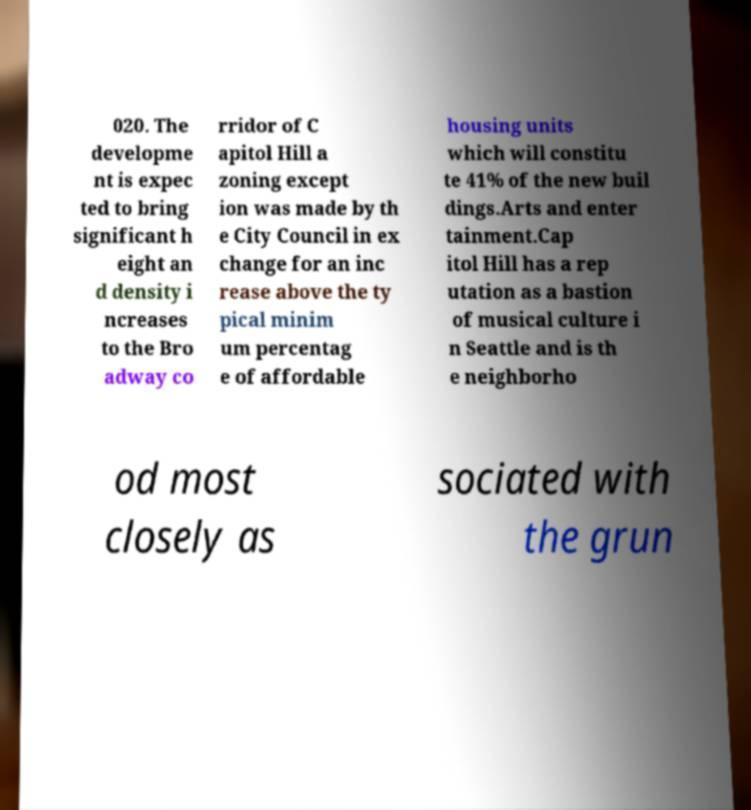There's text embedded in this image that I need extracted. Can you transcribe it verbatim? 020. The developme nt is expec ted to bring significant h eight an d density i ncreases to the Bro adway co rridor of C apitol Hill a zoning except ion was made by th e City Council in ex change for an inc rease above the ty pical minim um percentag e of affordable housing units which will constitu te 41% of the new buil dings.Arts and enter tainment.Cap itol Hill has a rep utation as a bastion of musical culture i n Seattle and is th e neighborho od most closely as sociated with the grun 